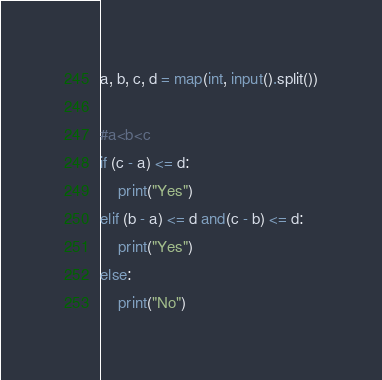<code> <loc_0><loc_0><loc_500><loc_500><_Python_>a, b, c, d = map(int, input().split())

#a<b<c
if (c - a) <= d:
    print("Yes")
elif (b - a) <= d and(c - b) <= d:
    print("Yes")
else:
    print("No")</code> 